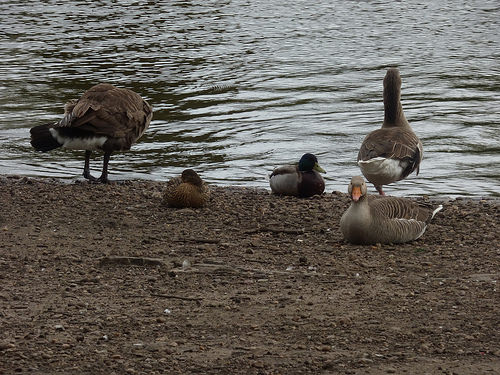<image>
Is the duck in the water? No. The duck is not contained within the water. These objects have a different spatial relationship. 